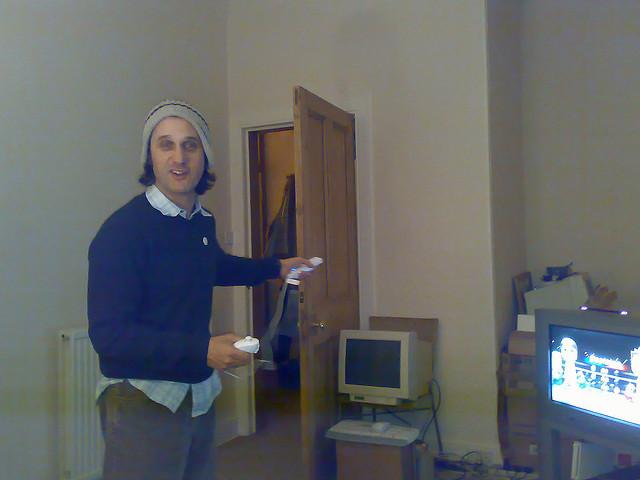What is on the computer game?
Short answer required. Boxing. What brand of athletic shirt is this man wearing?
Be succinct. Ralph lauren. Which room is this?
Keep it brief. Living room. What is the item directly behind the man?
Write a very short answer. Radiator. What color is the persons sweater?
Answer briefly. Blue. How many people are there?
Keep it brief. 1. What room is this?
Concise answer only. Living room. What is this person holding in their hands?
Keep it brief. Controller. Is this man looking at the monitor in front of him?
Short answer required. No. Was black and white the only available camera film back then?
Write a very short answer. No. What is gender of person standing?
Write a very short answer. Male. What type of hat is he wearing?
Concise answer only. Beanie. What is the red thing the man is holding in his left hand?
Write a very short answer. Nothing. What color are his eyes?
Write a very short answer. Blue. Is the computer turned on?
Quick response, please. No. Is this the best way to take a selfie?
Give a very brief answer. No. What does the man have on his neck?
Give a very brief answer. Collar. What is the white box behind the man?
Give a very brief answer. Radiator. Are the people facing the screen?
Short answer required. No. What kind of computer does he have?
Be succinct. Old. Is this man talking on a phone?
Concise answer only. No. What game is the man playing?
Write a very short answer. Wii. Is her computer turned on?
Keep it brief. No. What object is behind the man?
Keep it brief. Radiator. Is the man looking into the camera?
Short answer required. Yes. Does the man have long hair?
Give a very brief answer. Yes. Is this person's face completely hidden?
Write a very short answer. No. What is on this persons head?
Be succinct. Hat. Does this man need a toupee?
Be succinct. No. What is the man wearing?
Short answer required. Sweater. Which hand is pointing?
Give a very brief answer. Left. What is the thing sticking out behind him?
Quick response, please. Heater. Does he hold the winning entry?
Answer briefly. No. Is there a mirror in the image?
Keep it brief. No. Is this guy wearing a tie?
Answer briefly. No. What Wii game is this man playing?
Be succinct. Boxing. What kind of shirt is the man wearing?
Quick response, please. Sweater. Is the door in the background open or closed?
Short answer required. Open. What is this person doing?
Keep it brief. Playing wii. Why is the man wearing a hat inside?
Answer briefly. He's cold. Are there pictures on the wall?
Give a very brief answer. No. Is the man looking at the camera?
Be succinct. Yes. Is this an office?
Keep it brief. No. What color is the room?
Give a very brief answer. White. 